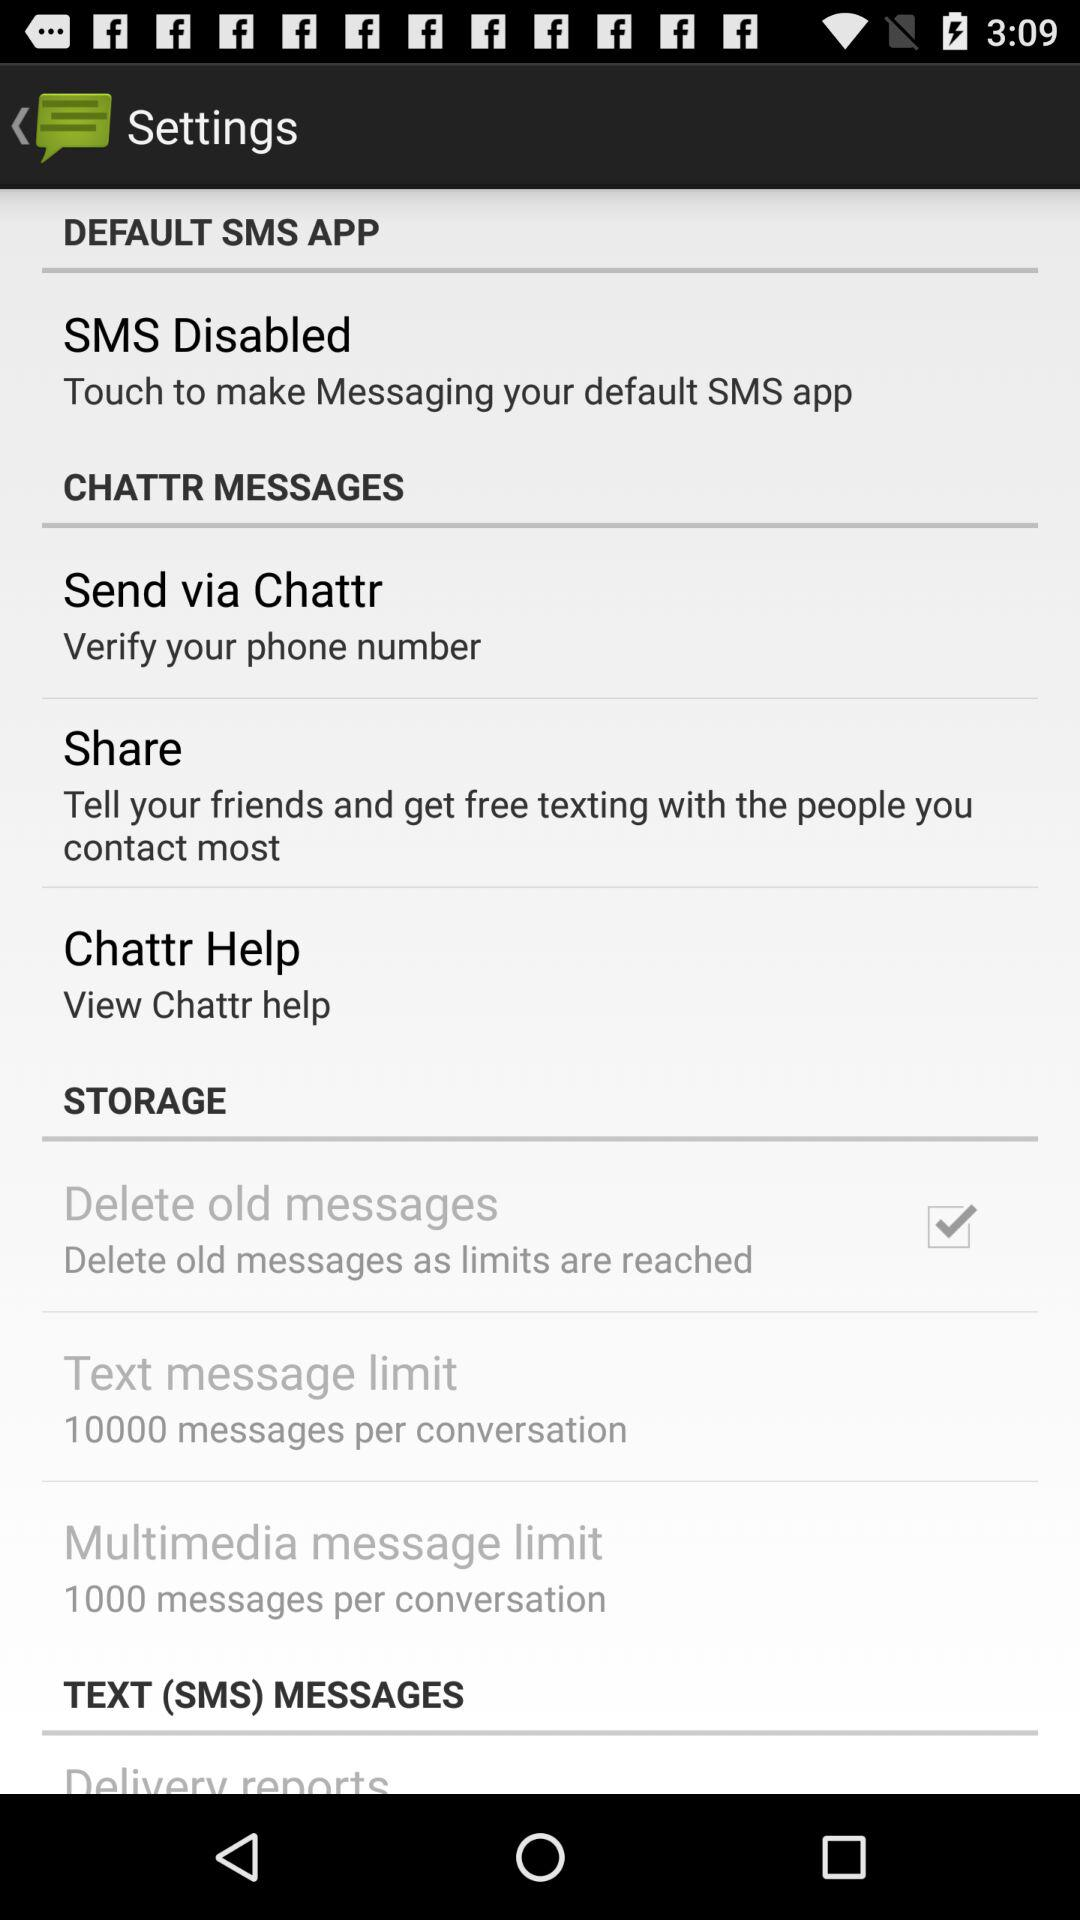What is the multimedia message limit? The multimedia messages limit is 1000 messages per conversation. 